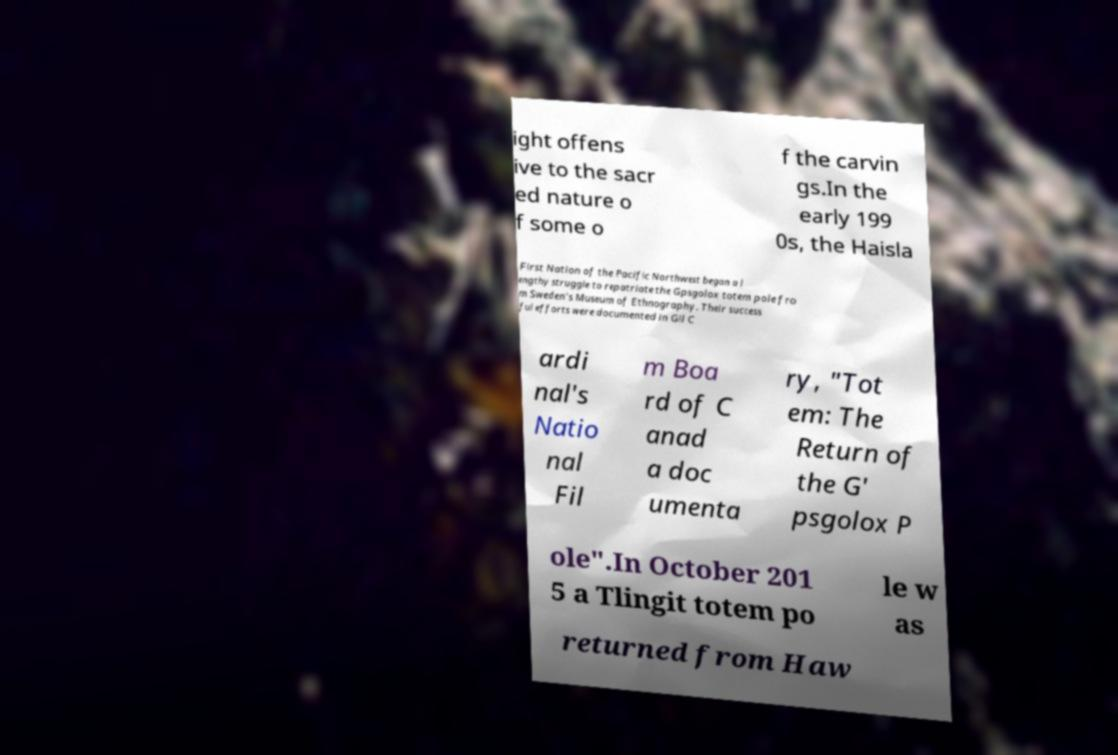What messages or text are displayed in this image? I need them in a readable, typed format. ight offens ive to the sacr ed nature o f some o f the carvin gs.In the early 199 0s, the Haisla First Nation of the Pacific Northwest began a l engthy struggle to repatriate the Gpsgolox totem pole fro m Sweden's Museum of Ethnography. Their success ful efforts were documented in Gil C ardi nal's Natio nal Fil m Boa rd of C anad a doc umenta ry, "Tot em: The Return of the G' psgolox P ole".In October 201 5 a Tlingit totem po le w as returned from Haw 